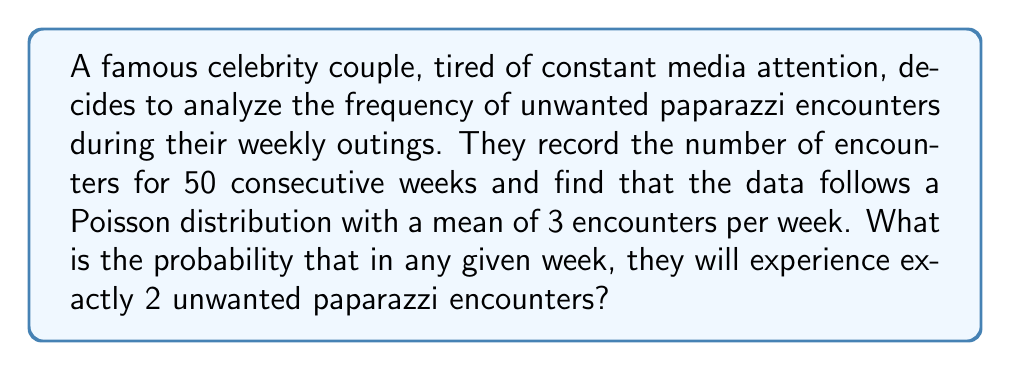Give your solution to this math problem. To solve this problem, we need to use the Poisson probability mass function. The Poisson distribution is used to model the number of events occurring in a fixed interval of time or space, given that these events occur with a known average rate and independently of the time since the last event.

The Poisson probability mass function is given by:

$$P(X = k) = \frac{e^{-\lambda} \lambda^k}{k!}$$

Where:
$\lambda$ is the average number of events per interval
$k$ is the number of events we're interested in
$e$ is Euler's number (approximately 2.71828)

Given:
$\lambda = 3$ (mean number of encounters per week)
$k = 2$ (we're interested in exactly 2 encounters)

Let's substitute these values into the formula:

$$P(X = 2) = \frac{e^{-3} 3^2}{2!}$$

Now, let's calculate step by step:

1) First, calculate $e^{-3}$:
   $e^{-3} \approx 0.0497870684$

2) Calculate $3^2$:
   $3^2 = 9$

3) Calculate $2!$:
   $2! = 2 \times 1 = 2$

4) Put it all together:
   $$P(X = 2) = \frac{0.0497870684 \times 9}{2} = 0.2240418076$$

5) Round to 4 decimal places:
   $P(X = 2) \approx 0.2240$

Therefore, the probability of exactly 2 unwanted paparazzi encounters in any given week is approximately 0.2240 or 22.40%.
Answer: 0.2240 or 22.40% 